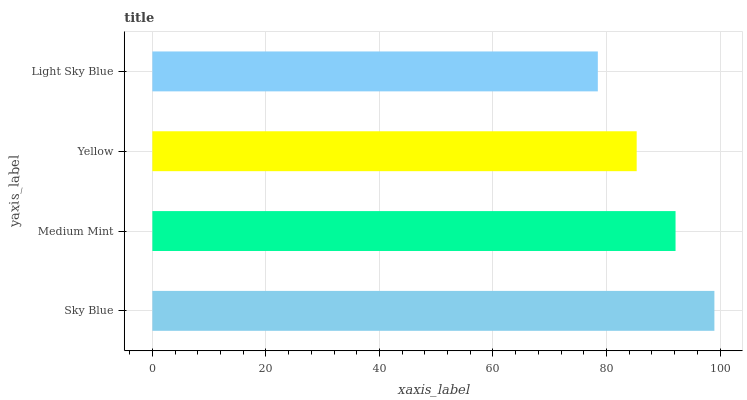Is Light Sky Blue the minimum?
Answer yes or no. Yes. Is Sky Blue the maximum?
Answer yes or no. Yes. Is Medium Mint the minimum?
Answer yes or no. No. Is Medium Mint the maximum?
Answer yes or no. No. Is Sky Blue greater than Medium Mint?
Answer yes or no. Yes. Is Medium Mint less than Sky Blue?
Answer yes or no. Yes. Is Medium Mint greater than Sky Blue?
Answer yes or no. No. Is Sky Blue less than Medium Mint?
Answer yes or no. No. Is Medium Mint the high median?
Answer yes or no. Yes. Is Yellow the low median?
Answer yes or no. Yes. Is Yellow the high median?
Answer yes or no. No. Is Light Sky Blue the low median?
Answer yes or no. No. 